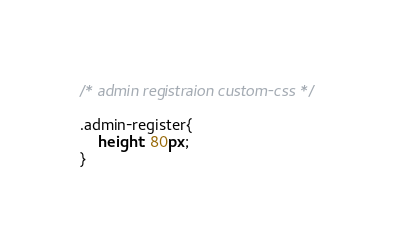<code> <loc_0><loc_0><loc_500><loc_500><_CSS_>
/* admin registraion custom-css */

.admin-register{
    height: 80px;
}
</code> 